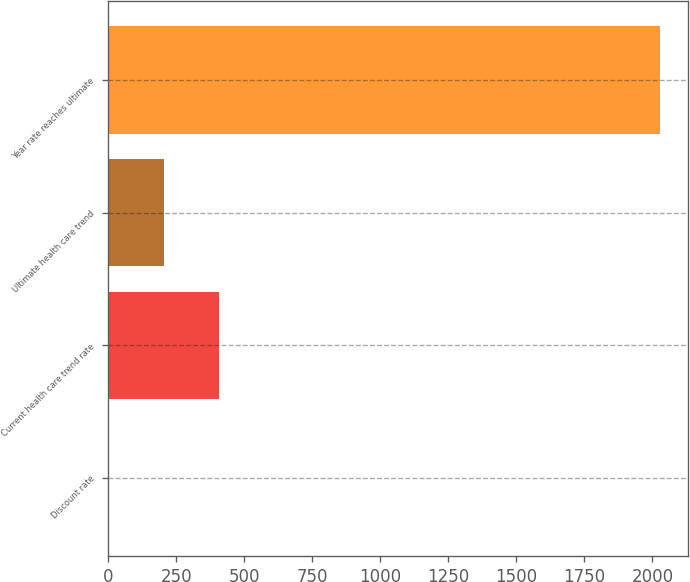Convert chart to OTSL. <chart><loc_0><loc_0><loc_500><loc_500><bar_chart><fcel>Discount rate<fcel>Current health care trend rate<fcel>Ultimate health care trend<fcel>Year rate reaches ultimate<nl><fcel>3.75<fcel>409<fcel>206.38<fcel>2030<nl></chart> 